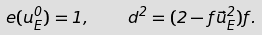<formula> <loc_0><loc_0><loc_500><loc_500>e ( u ^ { 0 } _ { E } ) = 1 , \quad d ^ { 2 } = ( 2 - f \vec { u } _ { E } ^ { 2 } ) f .</formula> 